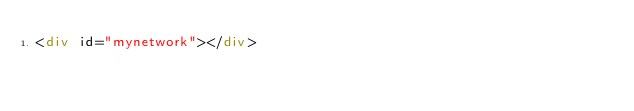<code> <loc_0><loc_0><loc_500><loc_500><_HTML_><div id="mynetwork"></div></code> 